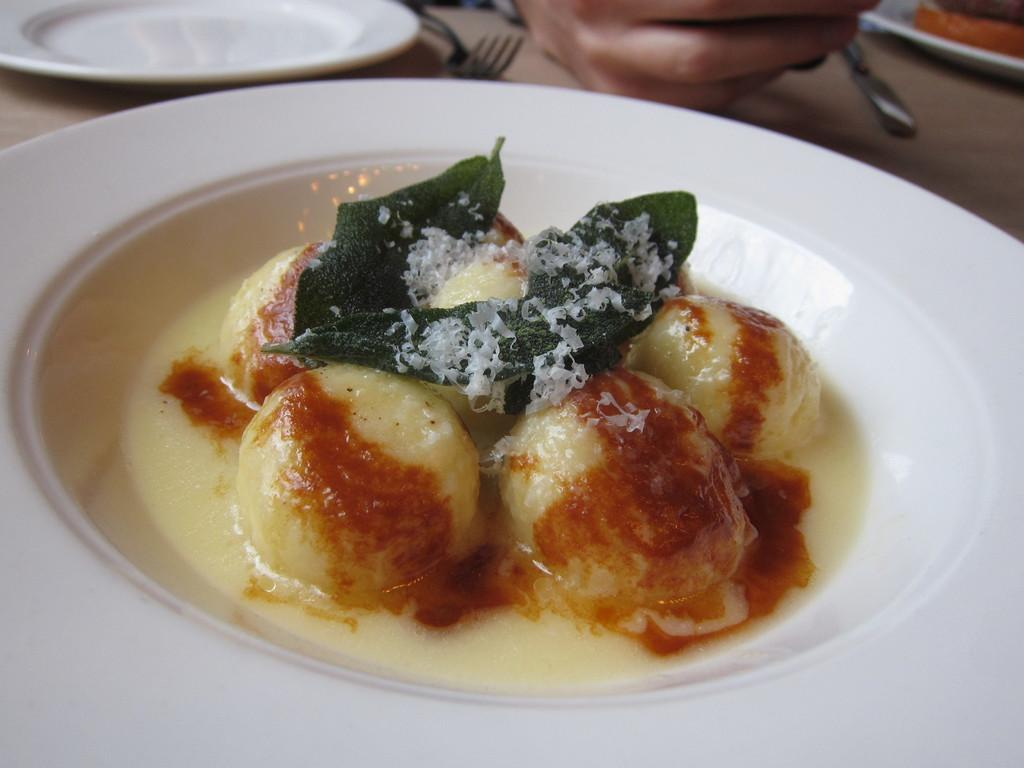What is on the plate that is visible in the front of the image? There is food on a white plate in the front of the image. How many plates can be seen in the image? There are plates visible in the image. What is on the plates? There is food on the plates. What utensils are present in the image? A fork and a knife are present in the image. What part of a person can be seen in the image? Fingers of a person are on the table. What type of coil is wrapped around the fork in the image? There is no coil present in the image, and the fork is not wrapped around anything. 